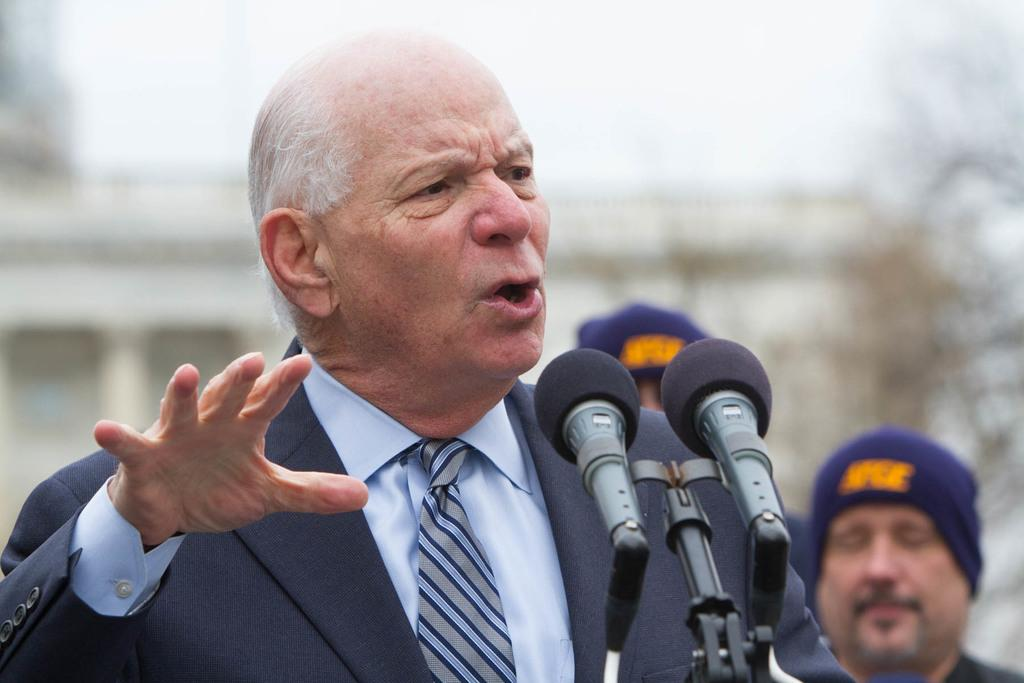How many people are in the image? There is a group of people in the image. Can you describe the attire of one of the individuals? One person is wearing a blue color blazer. What is the person in the blue blazer doing in the image? The person in the blue blazer is talking in front of microphones. What can be seen in the background of the image? The sky is visible in the background of the image. What is the color of the sky in the image? The color of the sky is white. Where is the stove located in the image? There is no stove present in the image. What type of ring is the person in the blue blazer wearing in the image? There is no ring visible on the person in the blue blazer in the image. 